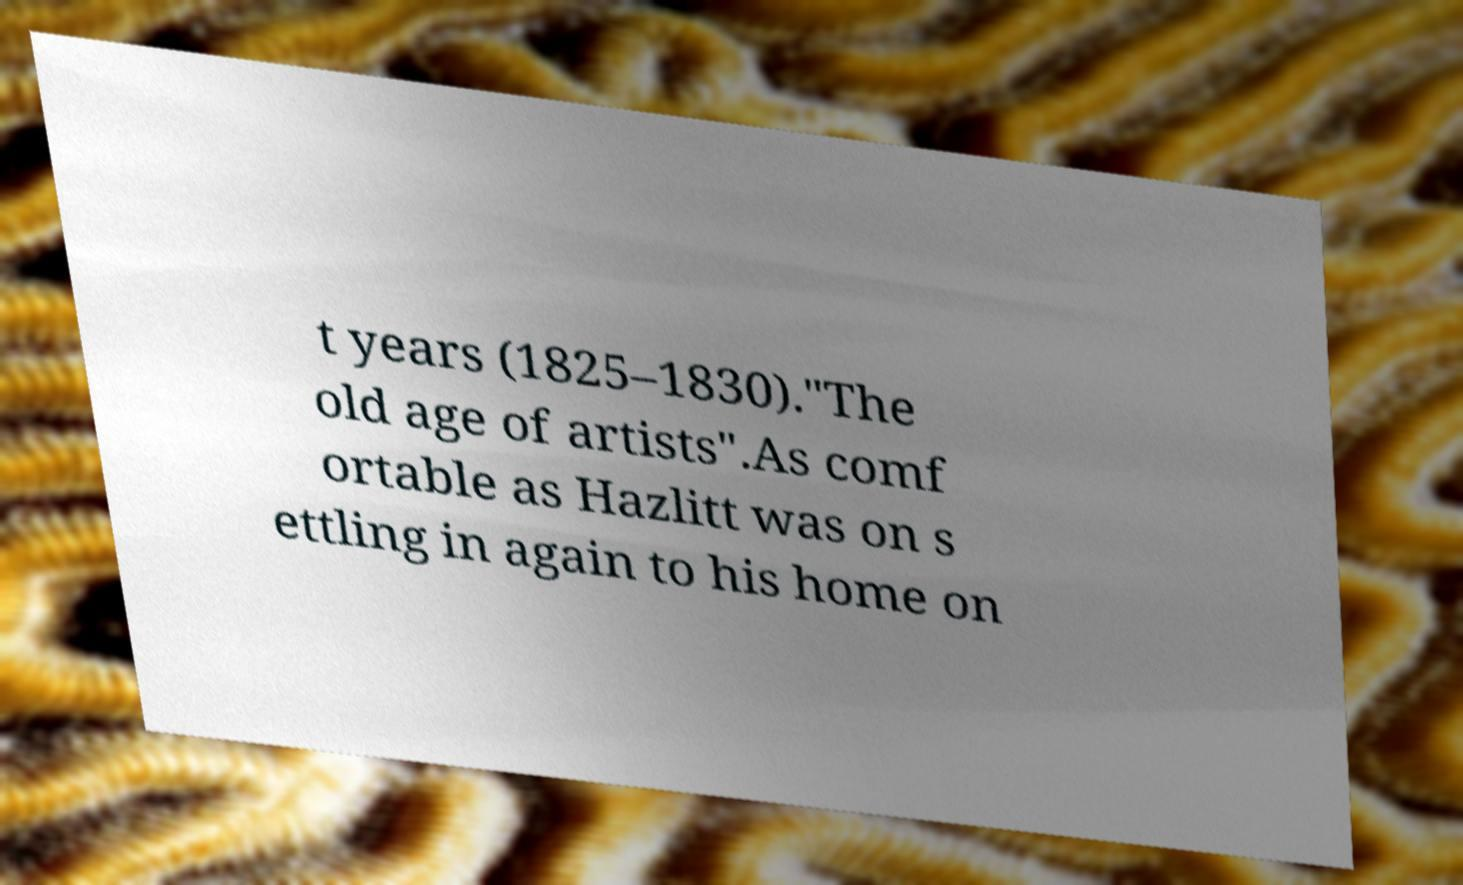What messages or text are displayed in this image? I need them in a readable, typed format. t years (1825–1830)."The old age of artists".As comf ortable as Hazlitt was on s ettling in again to his home on 